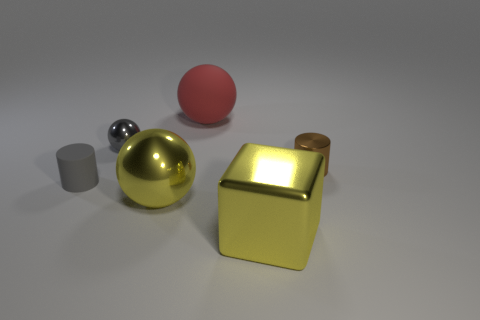Add 2 big cyan things. How many objects exist? 8 Subtract all blocks. How many objects are left? 5 Subtract 0 gray blocks. How many objects are left? 6 Subtract all small brown metallic cylinders. Subtract all rubber balls. How many objects are left? 4 Add 5 metallic cylinders. How many metallic cylinders are left? 6 Add 5 brown metal objects. How many brown metal objects exist? 6 